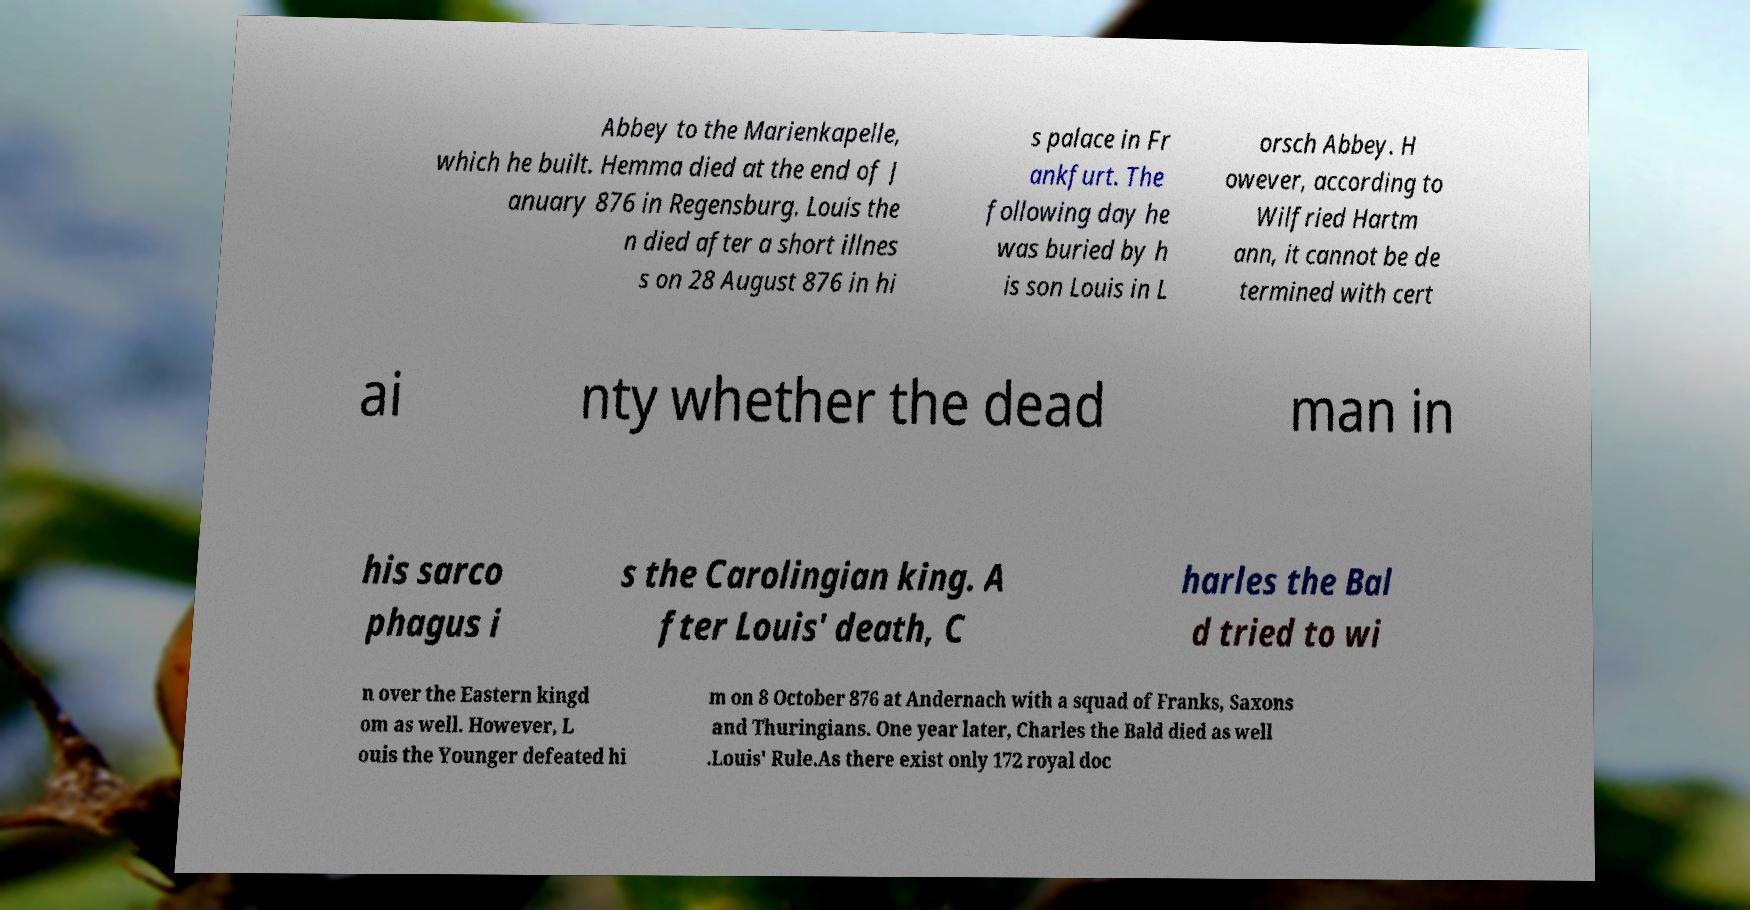There's text embedded in this image that I need extracted. Can you transcribe it verbatim? Abbey to the Marienkapelle, which he built. Hemma died at the end of J anuary 876 in Regensburg. Louis the n died after a short illnes s on 28 August 876 in hi s palace in Fr ankfurt. The following day he was buried by h is son Louis in L orsch Abbey. H owever, according to Wilfried Hartm ann, it cannot be de termined with cert ai nty whether the dead man in his sarco phagus i s the Carolingian king. A fter Louis' death, C harles the Bal d tried to wi n over the Eastern kingd om as well. However, L ouis the Younger defeated hi m on 8 October 876 at Andernach with a squad of Franks, Saxons and Thuringians. One year later, Charles the Bald died as well .Louis' Rule.As there exist only 172 royal doc 